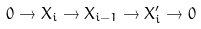<formula> <loc_0><loc_0><loc_500><loc_500>0 \to X _ { i } \to X _ { i - 1 } \to X _ { i } ^ { \prime } \to 0</formula> 